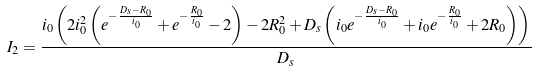<formula> <loc_0><loc_0><loc_500><loc_500>I _ { 2 } = \frac { i _ { 0 } \left ( 2 i _ { 0 } ^ { 2 } \left ( e ^ { - \frac { D _ { s } - R _ { 0 } } { i _ { 0 } } } + e ^ { - \frac { R _ { 0 } } { i _ { 0 } } } - 2 \right ) - 2 R _ { 0 } ^ { 2 } + D _ { s } \left ( i _ { 0 } e ^ { - \frac { D _ { s } - R _ { 0 } } { i _ { 0 } } } + i _ { 0 } e ^ { - \frac { R _ { 0 } } { i _ { 0 } } } + 2 R _ { 0 } \right ) \right ) } { D _ { s } }</formula> 